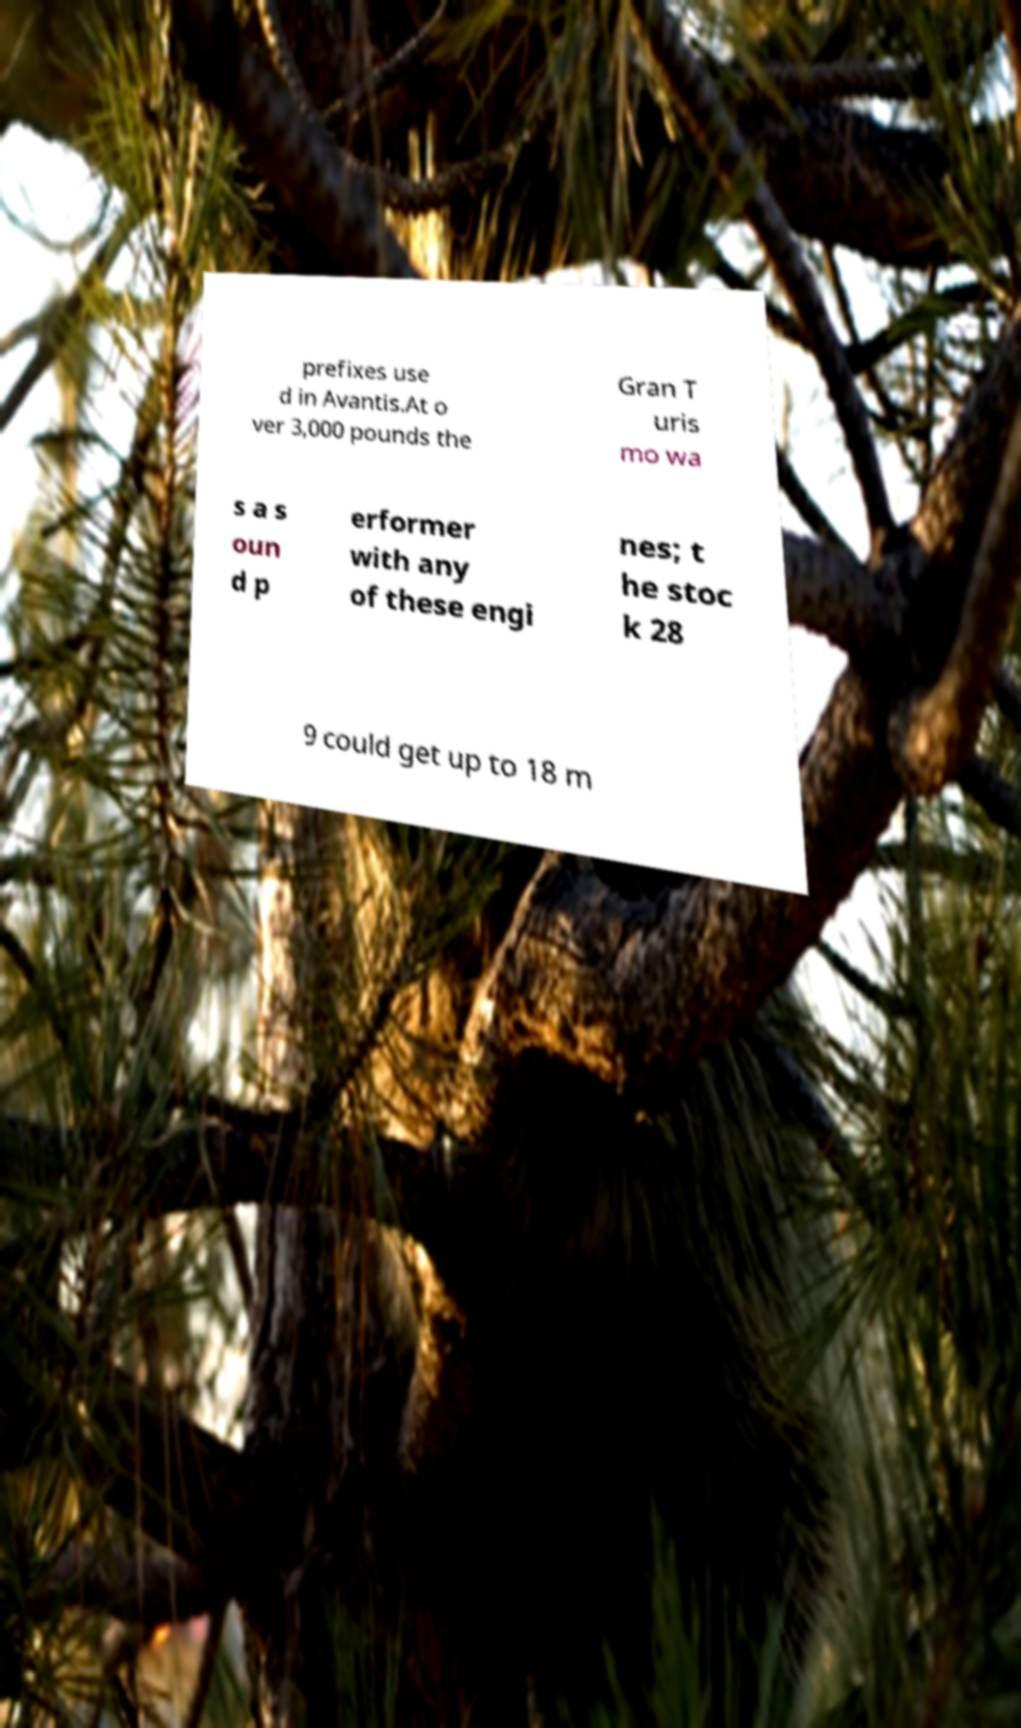I need the written content from this picture converted into text. Can you do that? prefixes use d in Avantis.At o ver 3,000 pounds the Gran T uris mo wa s a s oun d p erformer with any of these engi nes; t he stoc k 28 9 could get up to 18 m 